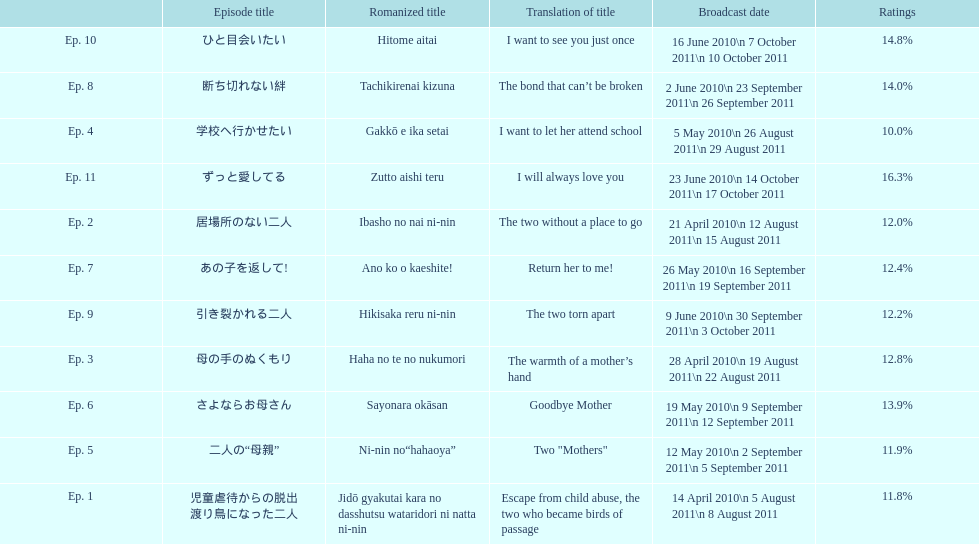How many episode total are there? 11. 